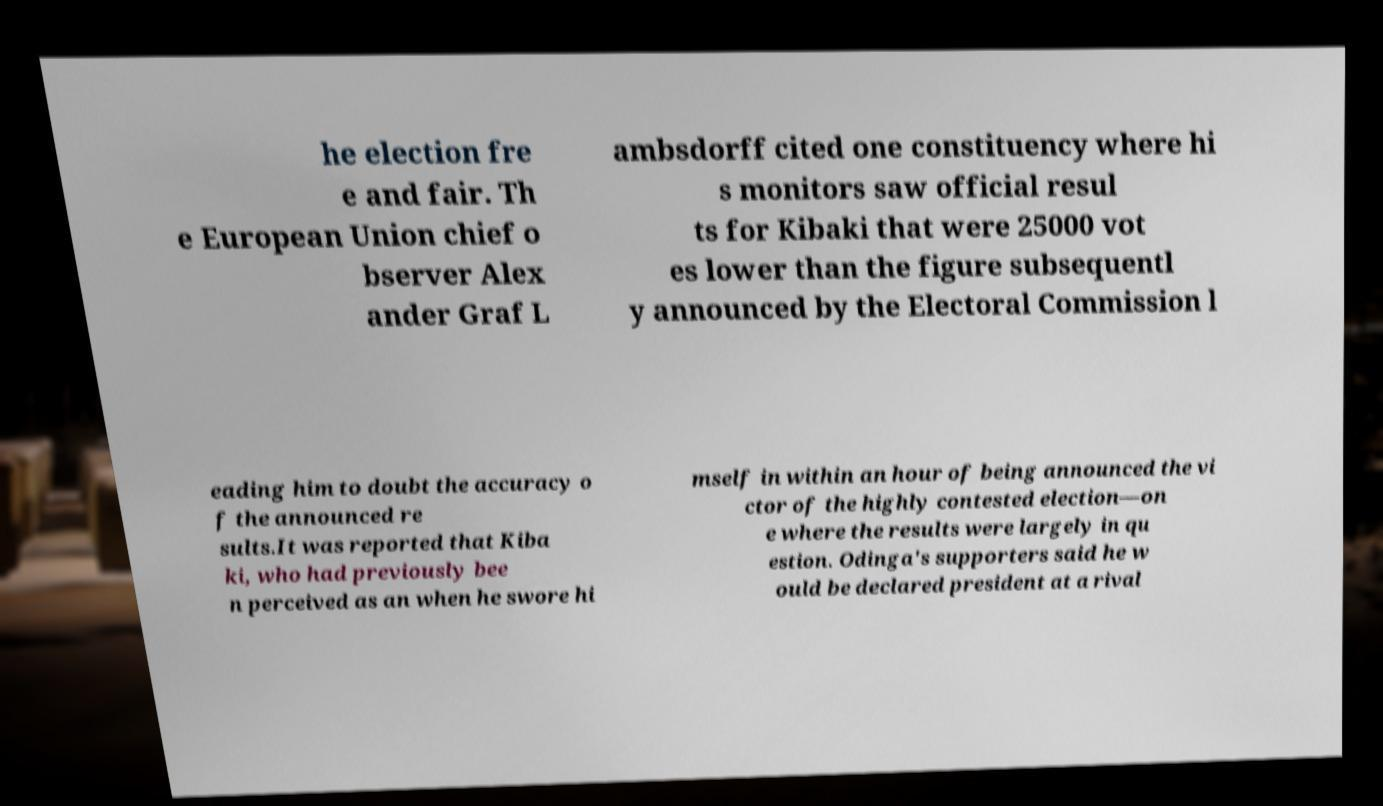Please identify and transcribe the text found in this image. he election fre e and fair. Th e European Union chief o bserver Alex ander Graf L ambsdorff cited one constituency where hi s monitors saw official resul ts for Kibaki that were 25000 vot es lower than the figure subsequentl y announced by the Electoral Commission l eading him to doubt the accuracy o f the announced re sults.It was reported that Kiba ki, who had previously bee n perceived as an when he swore hi mself in within an hour of being announced the vi ctor of the highly contested election—on e where the results were largely in qu estion. Odinga's supporters said he w ould be declared president at a rival 